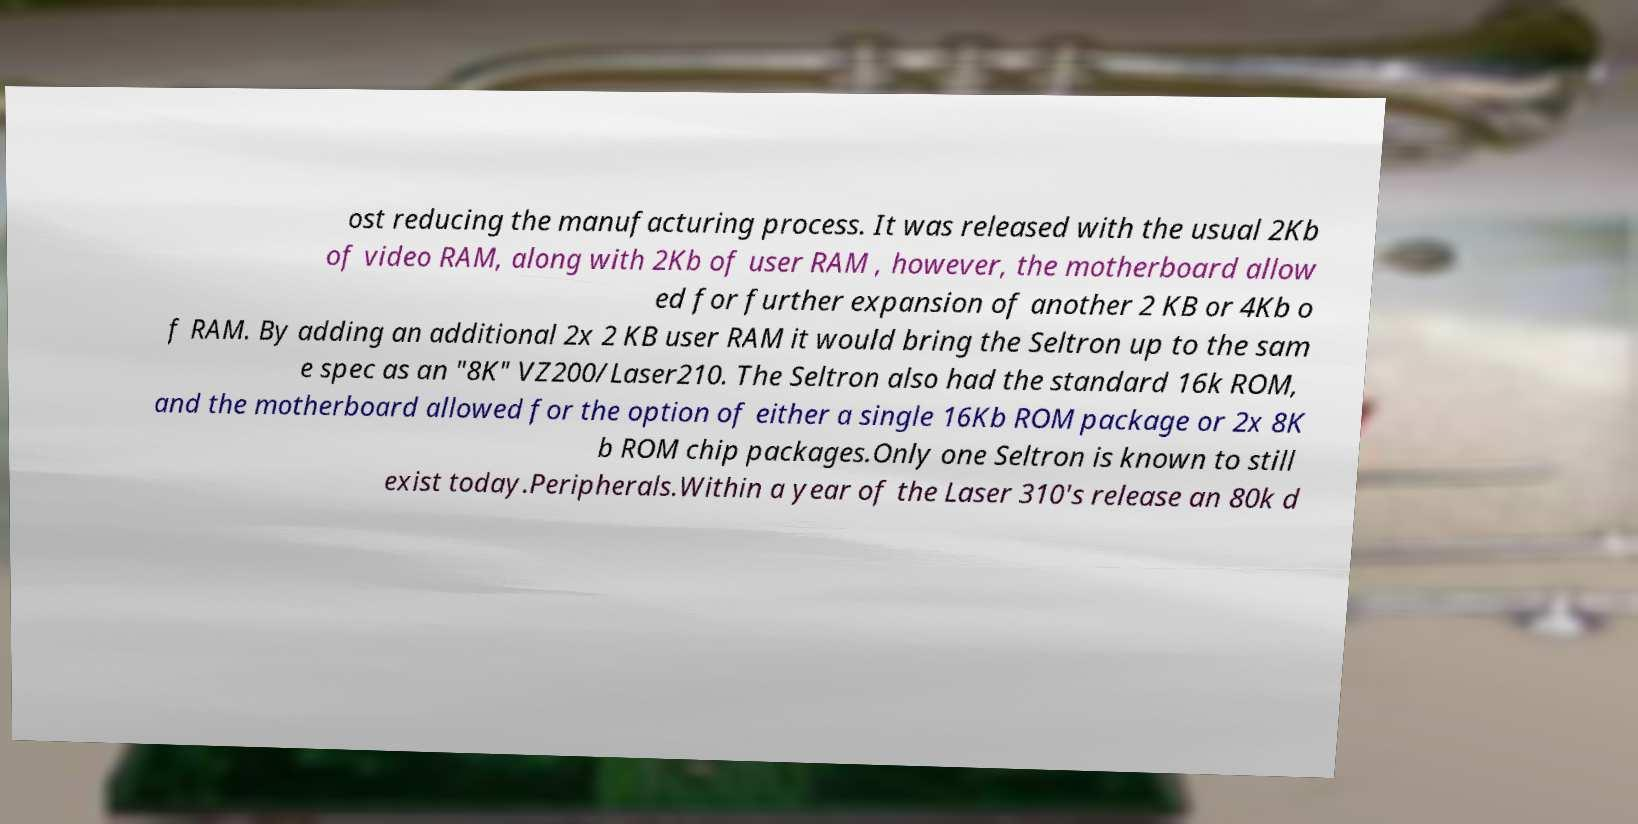Can you read and provide the text displayed in the image?This photo seems to have some interesting text. Can you extract and type it out for me? ost reducing the manufacturing process. It was released with the usual 2Kb of video RAM, along with 2Kb of user RAM , however, the motherboard allow ed for further expansion of another 2 KB or 4Kb o f RAM. By adding an additional 2x 2 KB user RAM it would bring the Seltron up to the sam e spec as an "8K" VZ200/Laser210. The Seltron also had the standard 16k ROM, and the motherboard allowed for the option of either a single 16Kb ROM package or 2x 8K b ROM chip packages.Only one Seltron is known to still exist today.Peripherals.Within a year of the Laser 310's release an 80k d 